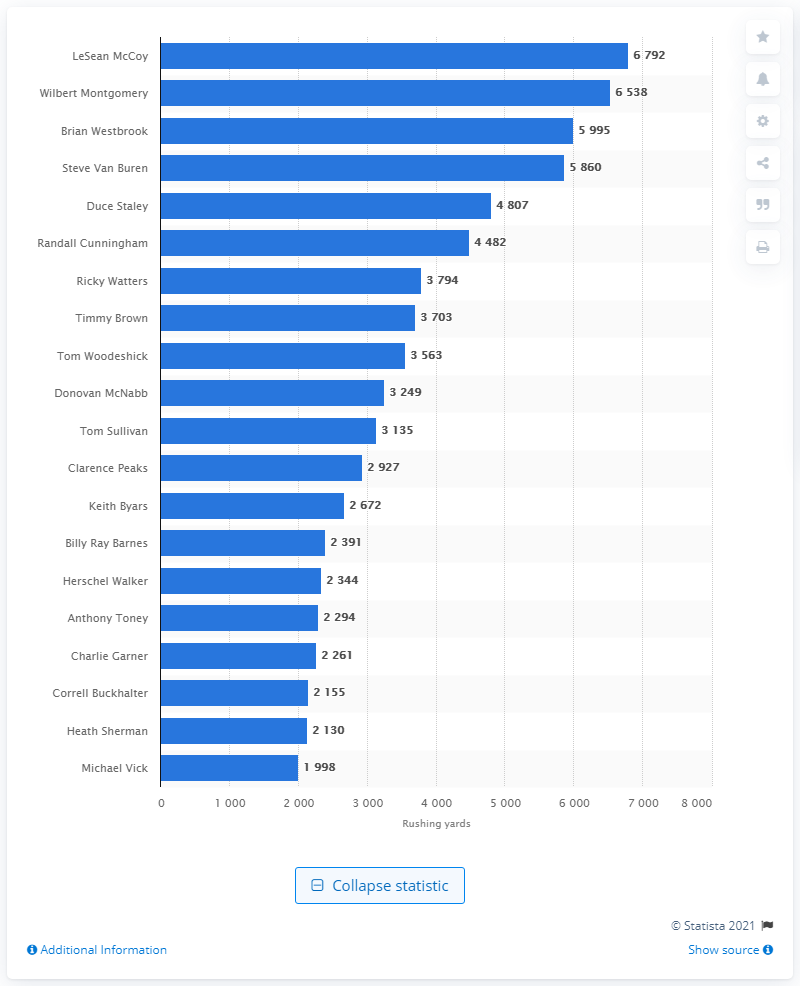Highlight a few significant elements in this photo. LeSean McCoy is the career rushing leader of the Philadelphia Eagles. 